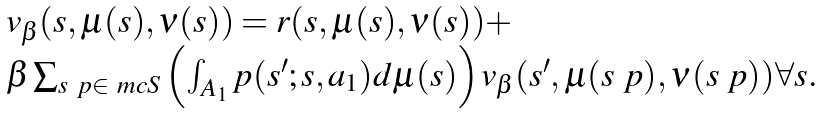<formula> <loc_0><loc_0><loc_500><loc_500>\begin{array} { l } v _ { \beta } ( s , \mu ( s ) , \nu ( s ) ) = r ( s , \mu ( s ) , \nu ( s ) ) + \\ \text {\indent \indent } \beta \sum _ { s \ p \in \ m c { S } } \left ( \int _ { A _ { 1 } } p ( s ^ { \prime } ; s , a _ { 1 } ) d \mu ( s ) \right ) v _ { \beta } ( s ^ { \prime } , \mu ( s \ p ) , \nu ( s \ p ) ) \text {\indent} \forall s . \end{array}</formula> 